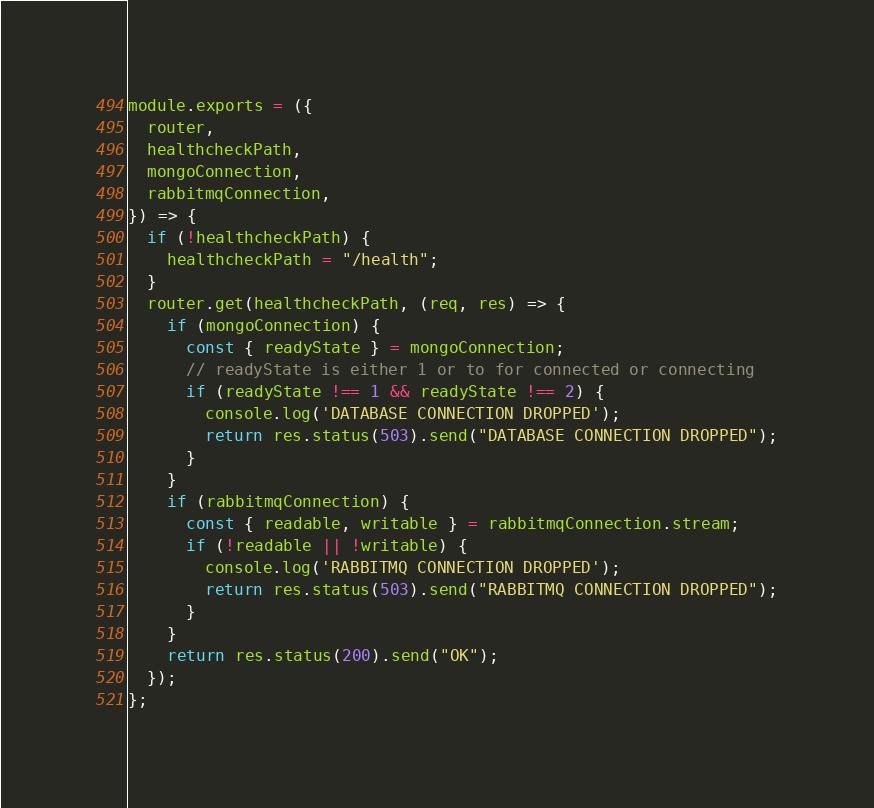<code> <loc_0><loc_0><loc_500><loc_500><_JavaScript_>module.exports = ({
  router,
  healthcheckPath,
  mongoConnection,
  rabbitmqConnection,
}) => {
  if (!healthcheckPath) {
    healthcheckPath = "/health";
  }
  router.get(healthcheckPath, (req, res) => {
    if (mongoConnection) {
      const { readyState } = mongoConnection;
      // readyState is either 1 or to for connected or connecting
      if (readyState !== 1 && readyState !== 2) {
        console.log('DATABASE CONNECTION DROPPED');
        return res.status(503).send("DATABASE CONNECTION DROPPED");
      }
    }
    if (rabbitmqConnection) {
      const { readable, writable } = rabbitmqConnection.stream;
      if (!readable || !writable) {
        console.log('RABBITMQ CONNECTION DROPPED');
        return res.status(503).send("RABBITMQ CONNECTION DROPPED");
      }
    }
    return res.status(200).send("OK");
  });
};
</code> 